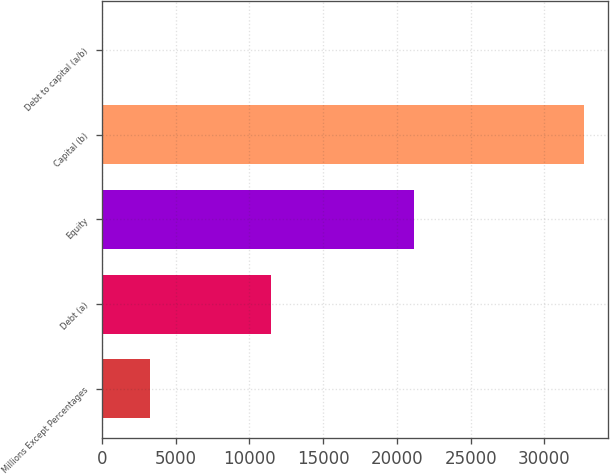Convert chart. <chart><loc_0><loc_0><loc_500><loc_500><bar_chart><fcel>Millions Except Percentages<fcel>Debt (a)<fcel>Equity<fcel>Capital (b)<fcel>Debt to capital (a/b)<nl><fcel>3298.49<fcel>11480<fcel>21189<fcel>32669<fcel>35.1<nl></chart> 